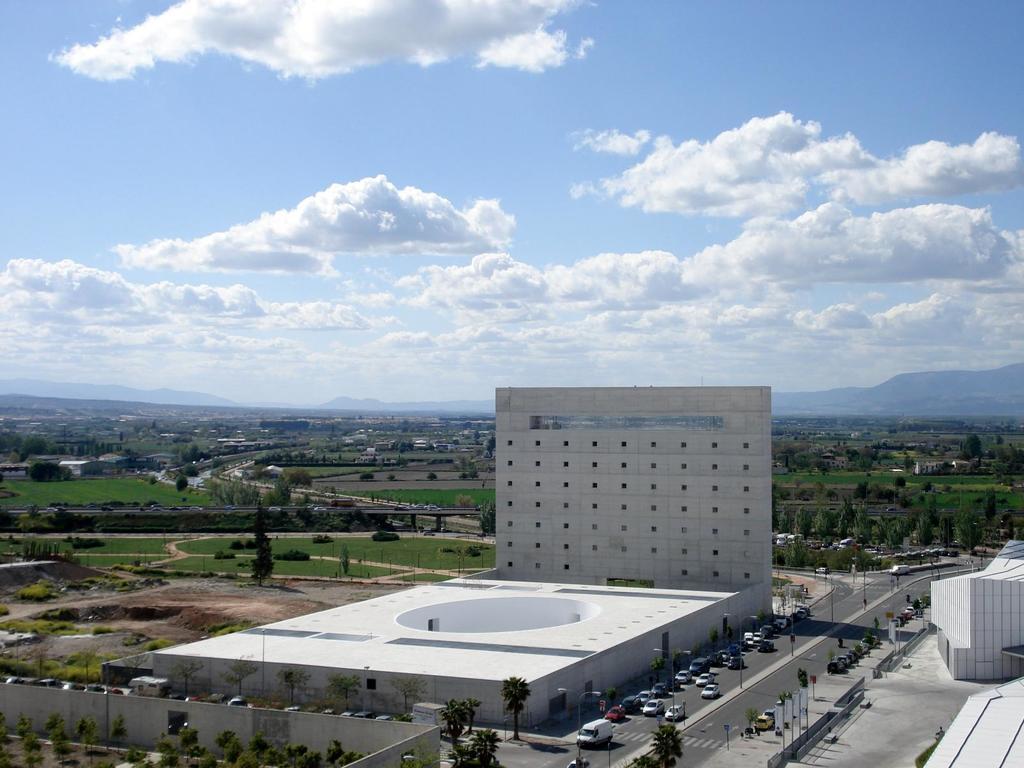Describe this image in one or two sentences. In this image I can see the road, number of vehicles on the road, few poles, few trees, the wall, few buildings, a bridge, few vehicles on the bridge and few mountains. In the background I can see the sky. 